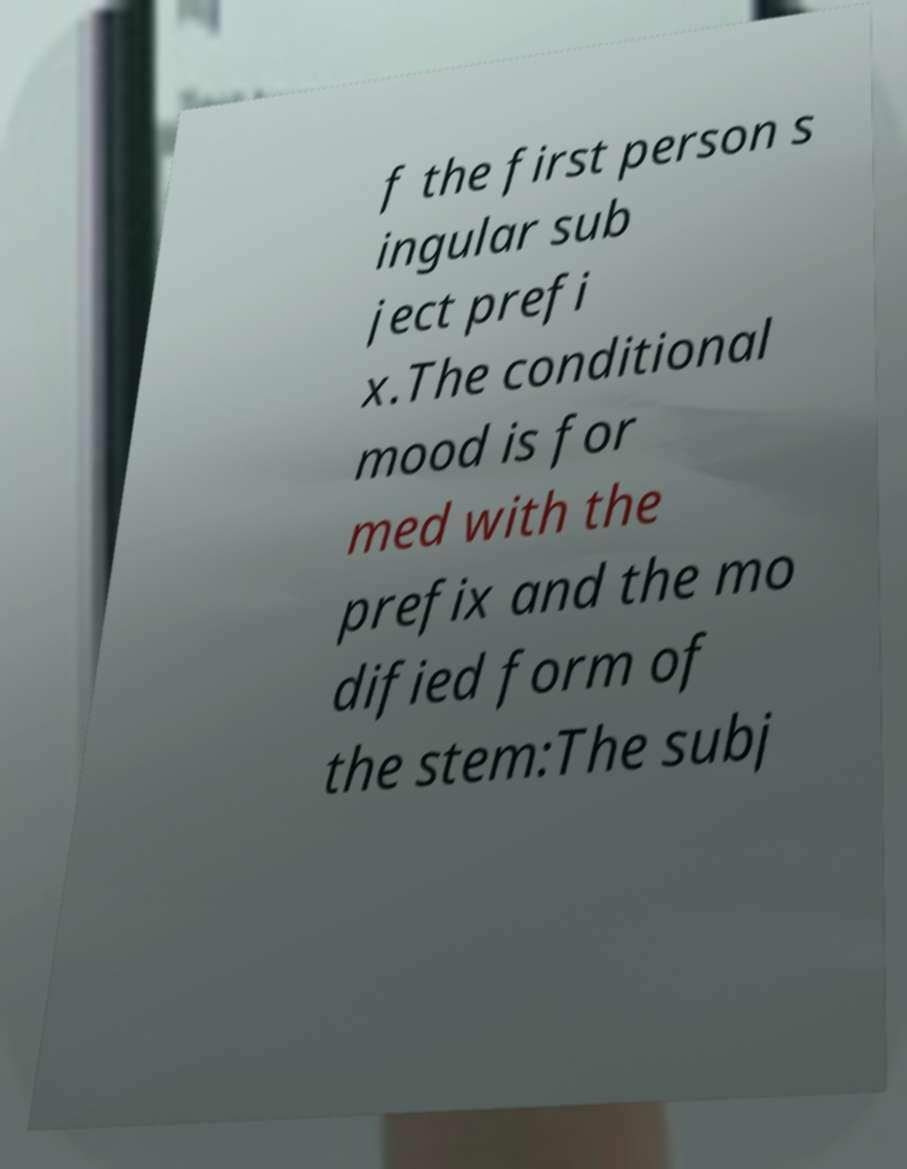Please identify and transcribe the text found in this image. f the first person s ingular sub ject prefi x.The conditional mood is for med with the prefix and the mo dified form of the stem:The subj 